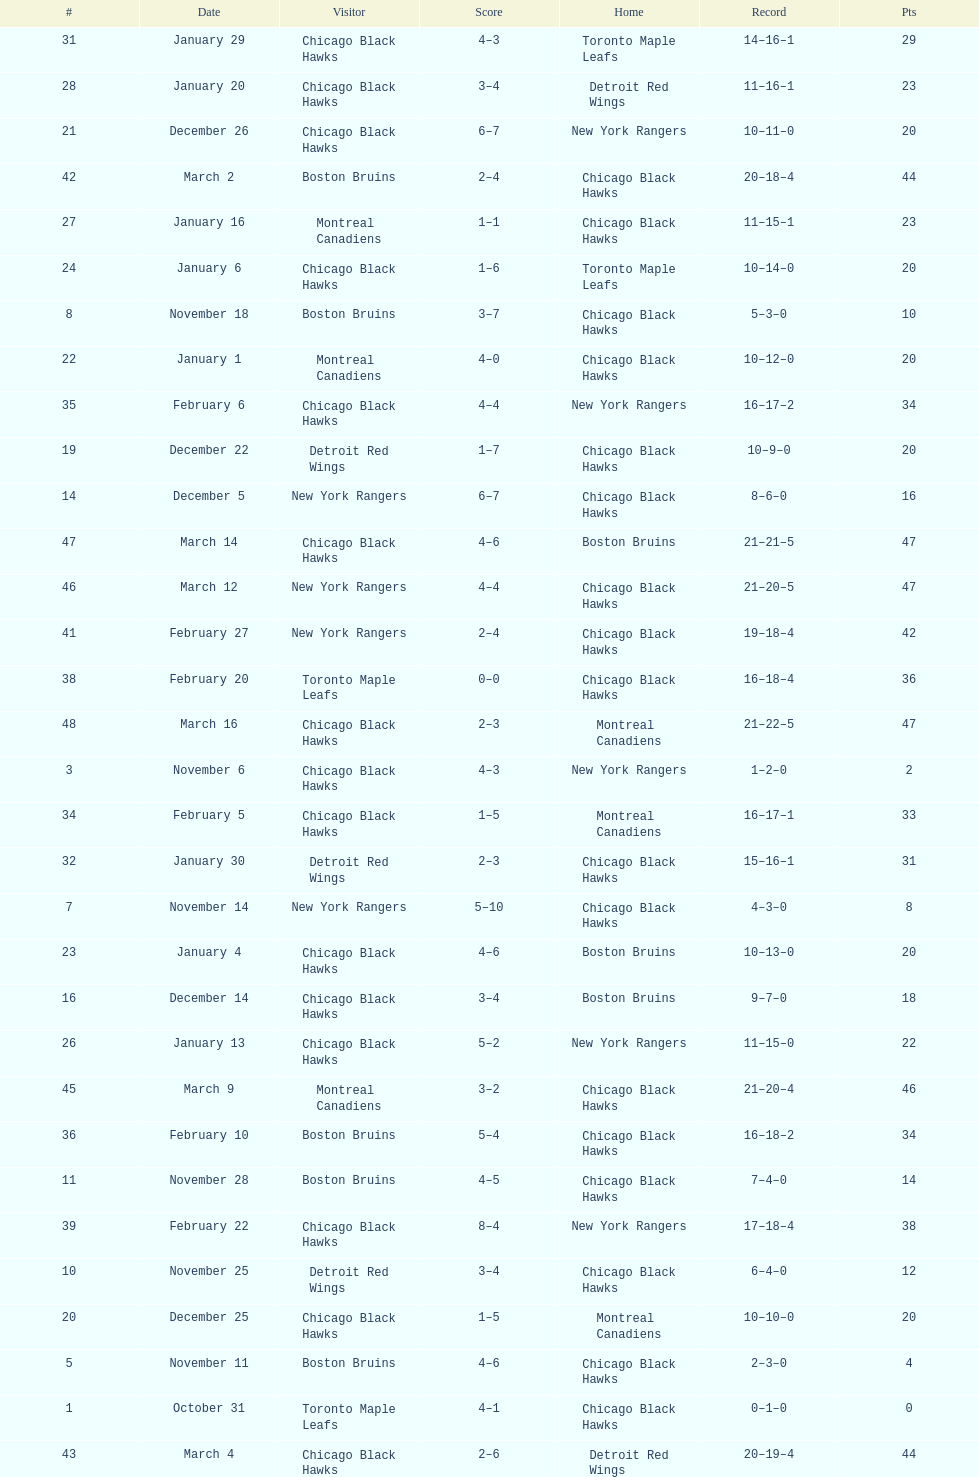How many total games did they win? 22. 